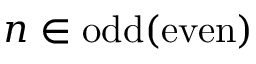Convert formula to latex. <formula><loc_0><loc_0><loc_500><loc_500>n \in o d d ( e v e n )</formula> 